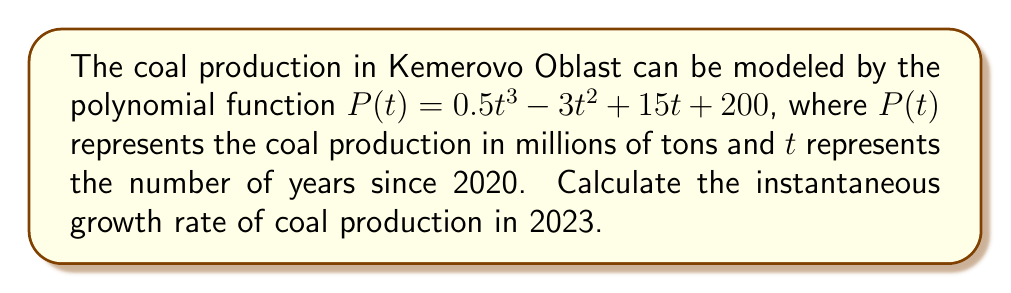Can you solve this math problem? To find the instantaneous growth rate, we need to calculate the derivative of the polynomial function and evaluate it at $t = 3$ (since 2023 is 3 years after 2020).

Step 1: Find the derivative of $P(t)$
$$P'(t) = \frac{d}{dt}(0.5t^3 - 3t^2 + 15t + 200)$$
$$P'(t) = 1.5t^2 - 6t + 15$$

Step 2: Evaluate $P'(t)$ at $t = 3$
$$P'(3) = 1.5(3)^2 - 6(3) + 15$$
$$P'(3) = 1.5(9) - 18 + 15$$
$$P'(3) = 13.5 - 18 + 15$$
$$P'(3) = 10.5$$

The instantaneous growth rate in 2023 is 10.5 million tons per year.
Answer: 10.5 million tons per year 